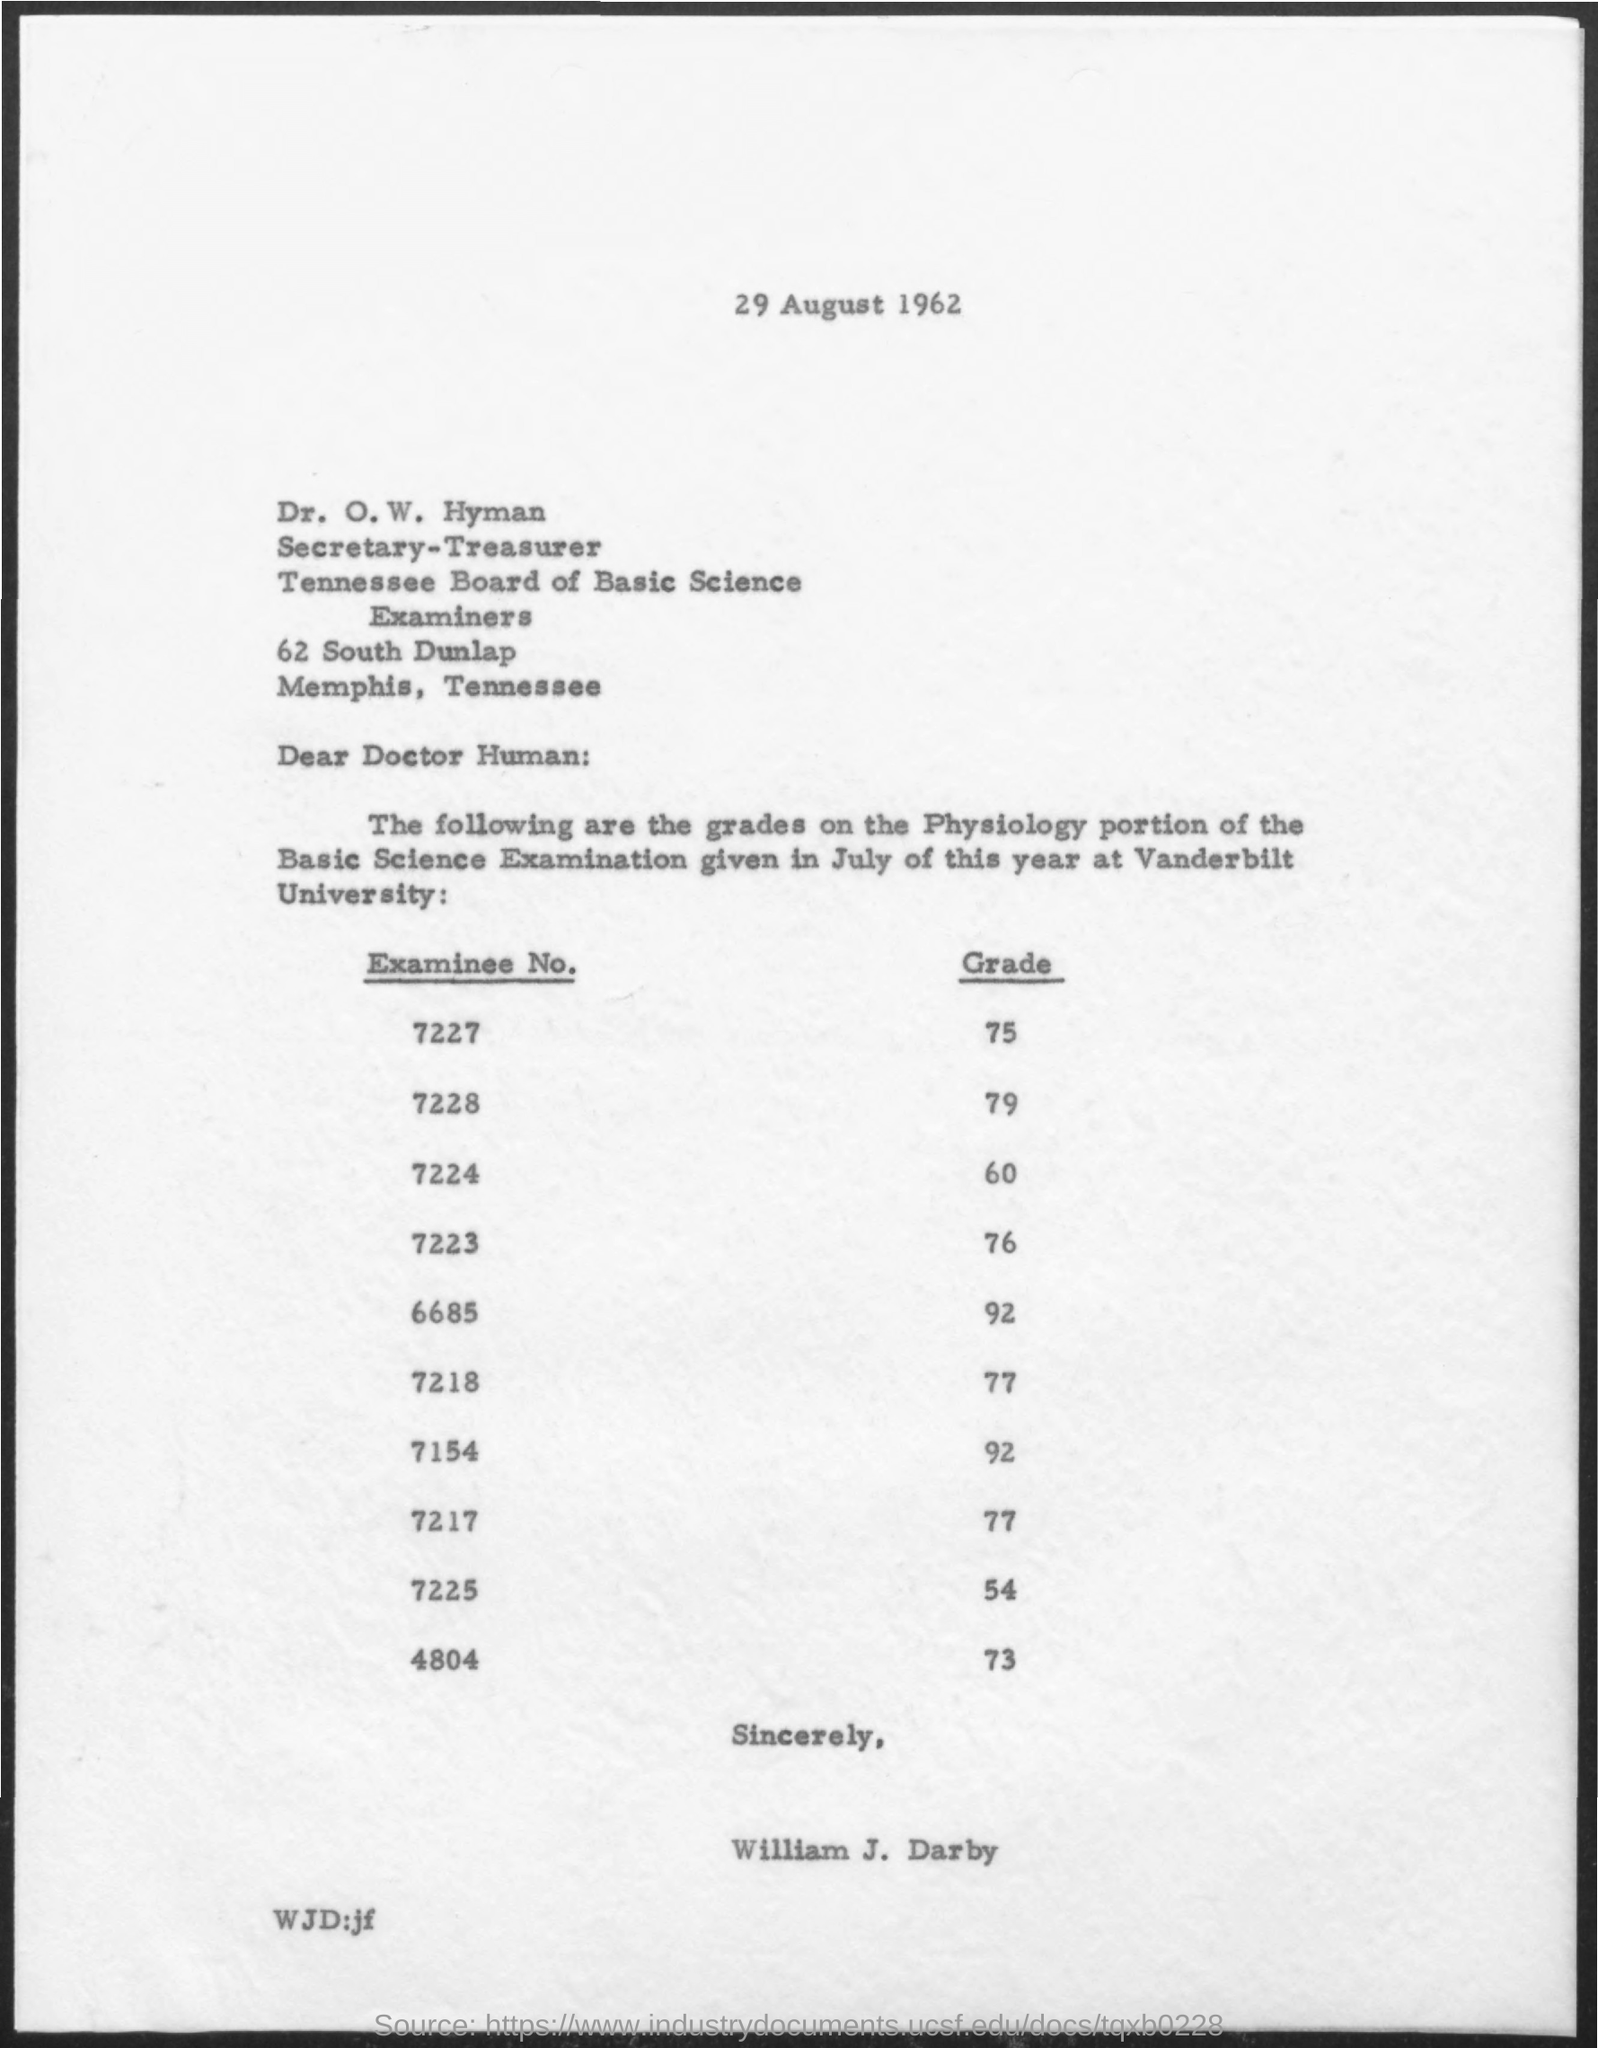What is the date on the document?
Your response must be concise. 29 August 1962. To Whom is this letter addressed to?
Ensure brevity in your answer.  O. W. Hyman. What is the Grade for Examinee No. 7227?
Offer a very short reply. 75. What is the Grade for Examinee No. 7228?
Your response must be concise. 79. What is the Grade for Examinee No. 7224?
Your response must be concise. 60. What is the Grade for Examinee No. 7223?
Your response must be concise. 76. What is the Grade for Examinee No. 6685?
Provide a succinct answer. 92. What is the Grade for Examinee No. 7218?
Your answer should be very brief. 77. What is the Grade for Examinee No. 7154?
Provide a short and direct response. 92. 